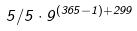Convert formula to latex. <formula><loc_0><loc_0><loc_500><loc_500>5 / 5 \cdot 9 ^ { ( 3 6 5 - 1 ) + 2 9 9 }</formula> 